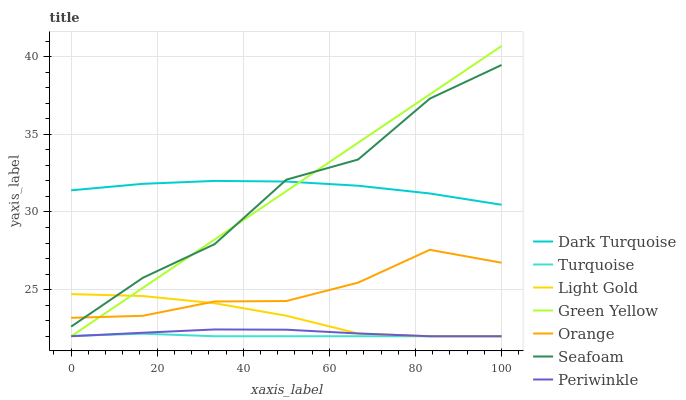Does Seafoam have the minimum area under the curve?
Answer yes or no. No. Does Seafoam have the maximum area under the curve?
Answer yes or no. No. Is Dark Turquoise the smoothest?
Answer yes or no. No. Is Dark Turquoise the roughest?
Answer yes or no. No. Does Seafoam have the lowest value?
Answer yes or no. No. Does Dark Turquoise have the highest value?
Answer yes or no. No. Is Periwinkle less than Dark Turquoise?
Answer yes or no. Yes. Is Orange greater than Periwinkle?
Answer yes or no. Yes. Does Periwinkle intersect Dark Turquoise?
Answer yes or no. No. 